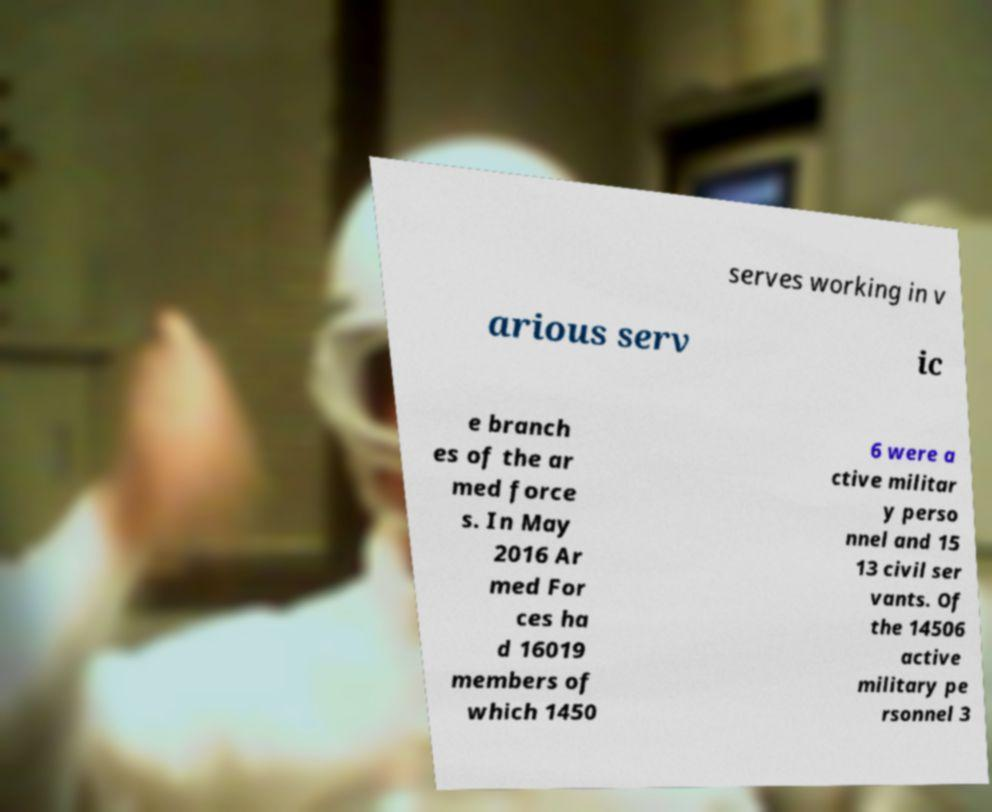Please read and relay the text visible in this image. What does it say? serves working in v arious serv ic e branch es of the ar med force s. In May 2016 Ar med For ces ha d 16019 members of which 1450 6 were a ctive militar y perso nnel and 15 13 civil ser vants. Of the 14506 active military pe rsonnel 3 